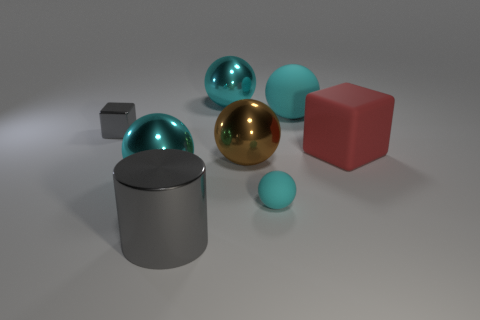Is the number of small balls that are behind the tiny cyan ball the same as the number of big yellow balls?
Offer a very short reply. Yes. What shape is the large gray metal object?
Provide a succinct answer. Cylinder. Is there any other thing that is the same color as the small ball?
Provide a succinct answer. Yes. Is the size of the gray cube behind the big matte cube the same as the cyan matte thing in front of the large red matte thing?
Offer a very short reply. Yes. What is the shape of the big gray object that is in front of the gray metal object behind the gray metal cylinder?
Provide a short and direct response. Cylinder. There is a shiny cylinder; is it the same size as the rubber ball behind the tiny cyan matte thing?
Your answer should be compact. Yes. There is a cyan rubber thing that is in front of the gray block that is to the left of the cyan ball to the right of the small rubber sphere; how big is it?
Offer a terse response. Small. How many objects are large spheres left of the brown thing or matte things?
Offer a terse response. 5. What number of large gray cylinders are right of the gray object that is to the left of the large cylinder?
Offer a terse response. 1. Is the number of cyan matte things to the right of the brown ball greater than the number of large purple matte cylinders?
Offer a terse response. Yes. 